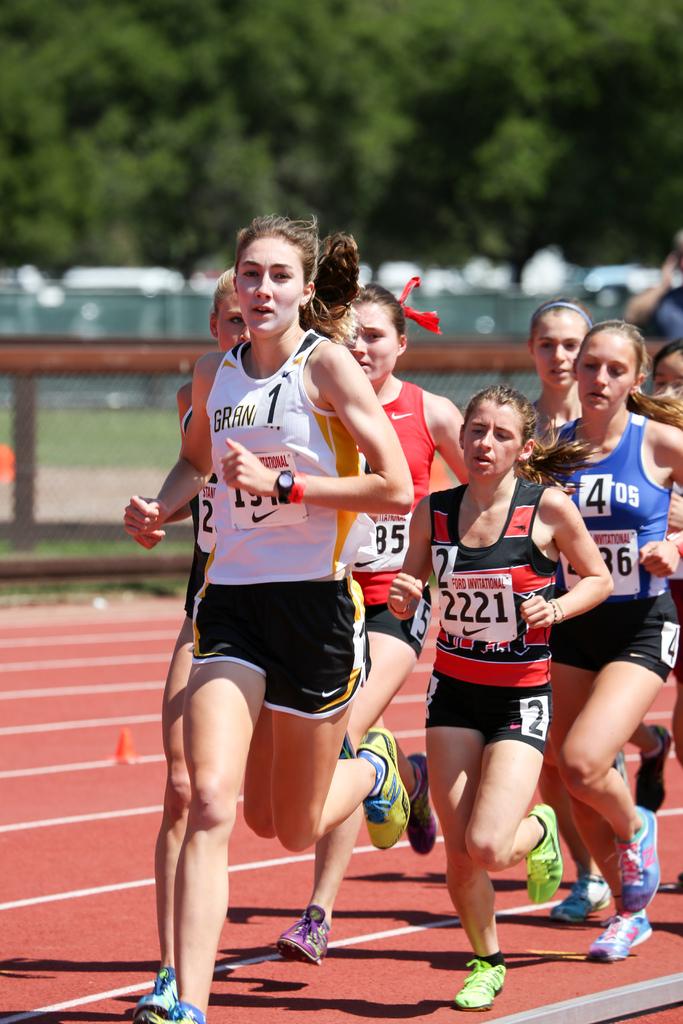Is runner 4 behind runner 2?
Offer a very short reply. Yes. 